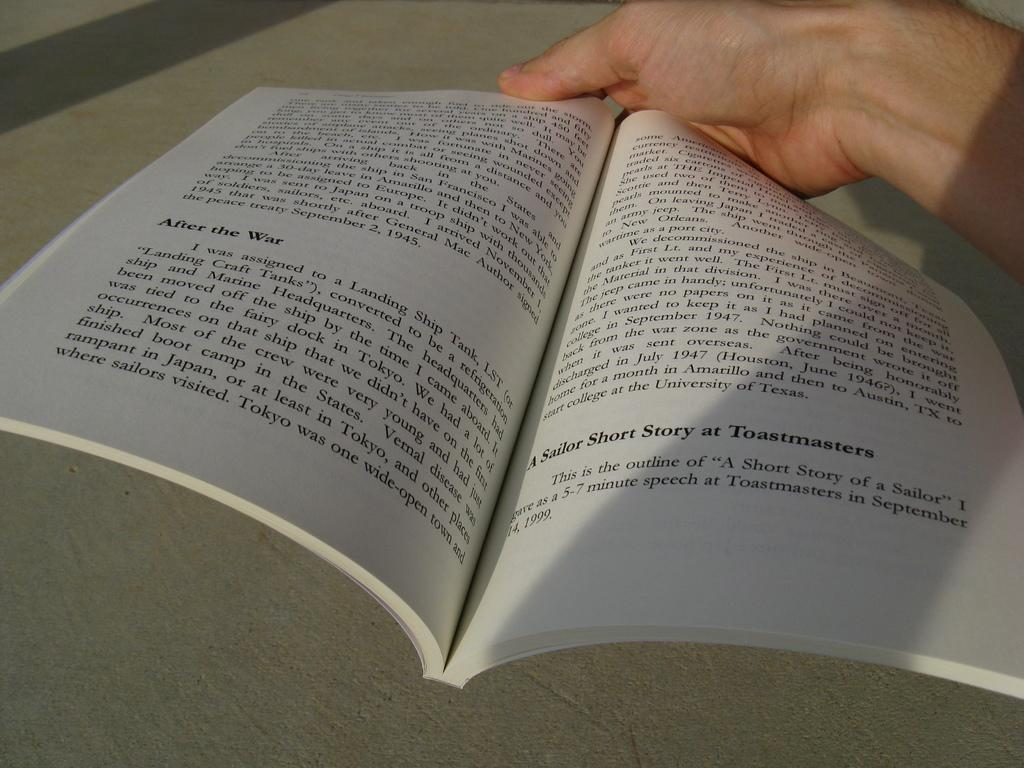<image>
Describe the image concisely. The book is full of short stories of only a few paragraphs each. 